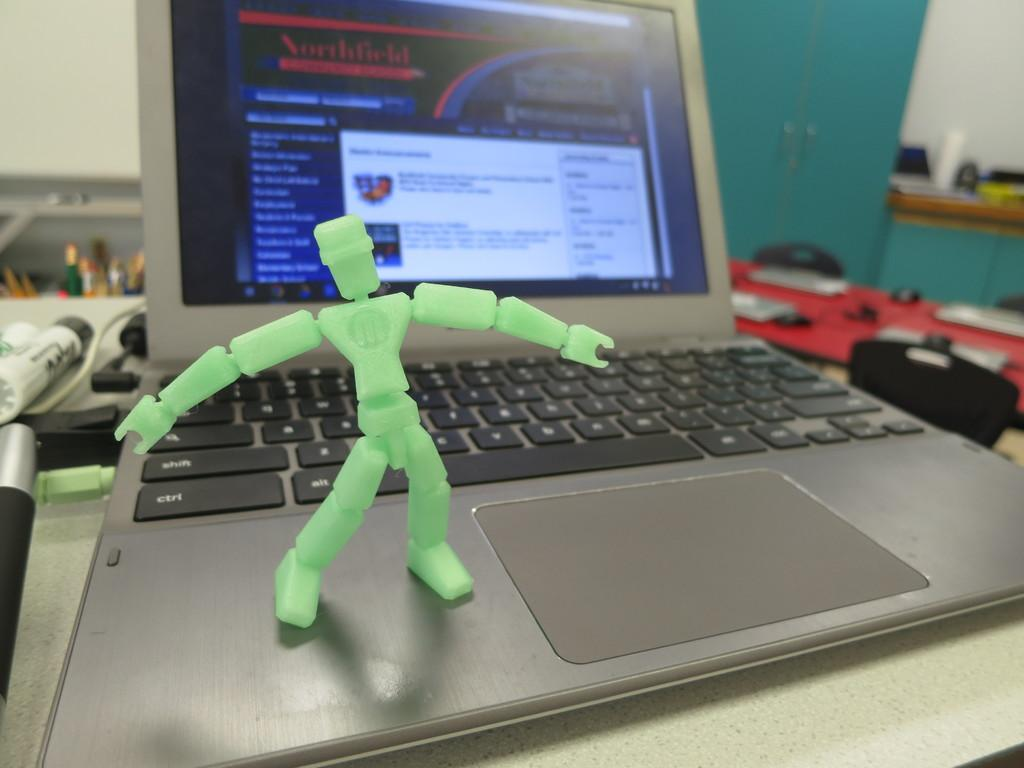<image>
Give a short and clear explanation of the subsequent image. A plastic green robot posed on the keyboard of a laptop computer that shows Northfield on the screen. 